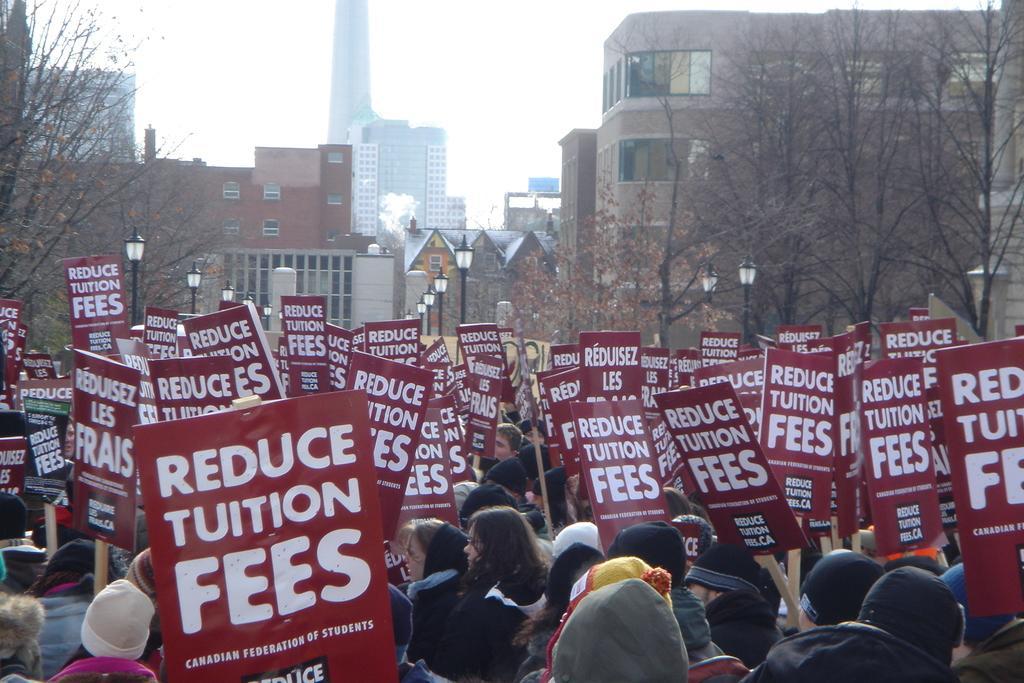Could you give a brief overview of what you see in this image? In this image we can see persons, boards and other objects. In the background of the image there are buildings, street lights, trees and other objects. At the top of the image there is the sky. 